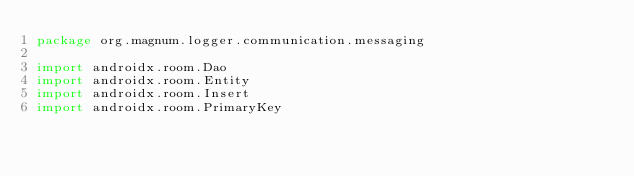Convert code to text. <code><loc_0><loc_0><loc_500><loc_500><_Kotlin_>package org.magnum.logger.communication.messaging

import androidx.room.Dao
import androidx.room.Entity
import androidx.room.Insert
import androidx.room.PrimaryKey
</code> 